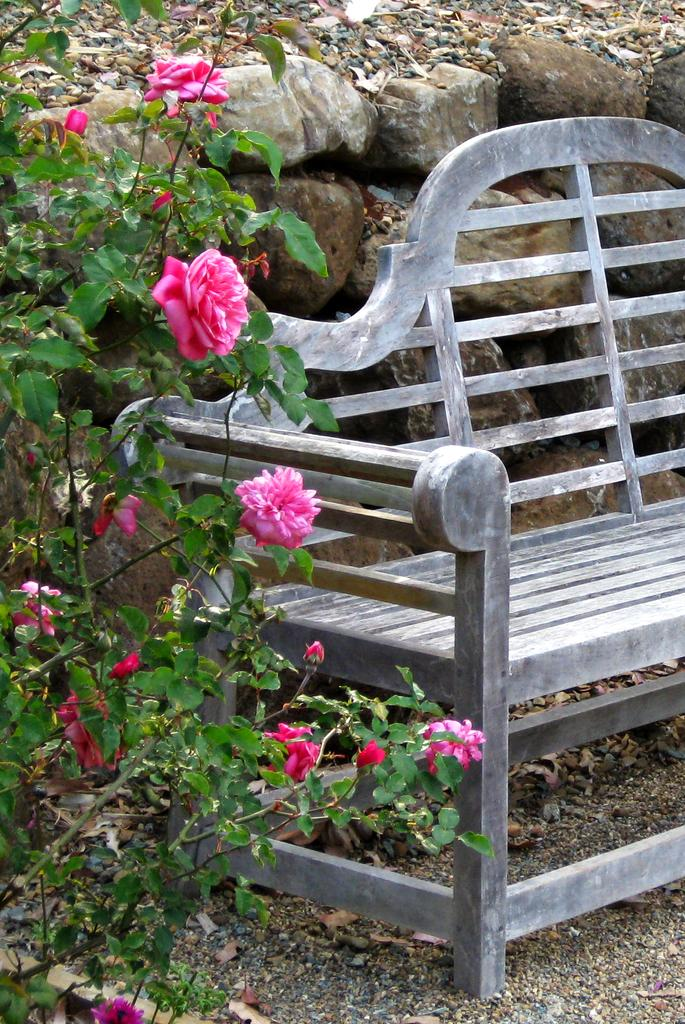What type of location might the image be taken from? The image may be taken from a garden. What can be seen on the right side of the image? There is a bench on the right side of the image. What type of plant is on the left side of the image? There is a plant of rose flowers on the left side of the image. What can be seen in the background of the image? There are stones and dry leaves present in the background of the image. What type of chin can be seen on the rose flowers in the image? There is no chin present in the image, as it features a plant of rose flowers and other elements of a garden. 